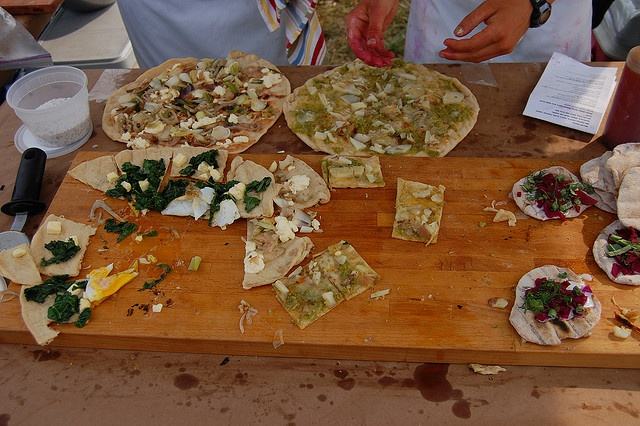Describe the objects in this image and their specific colors. I can see dining table in brown, maroon, and tan tones, pizza in brown, olive, gray, maroon, and tan tones, pizza in brown, gray, tan, olive, and maroon tones, people in brown, maroon, and gray tones, and people in brown and gray tones in this image. 